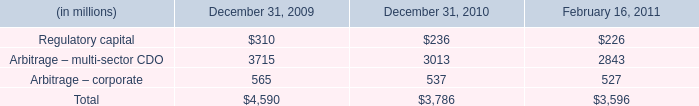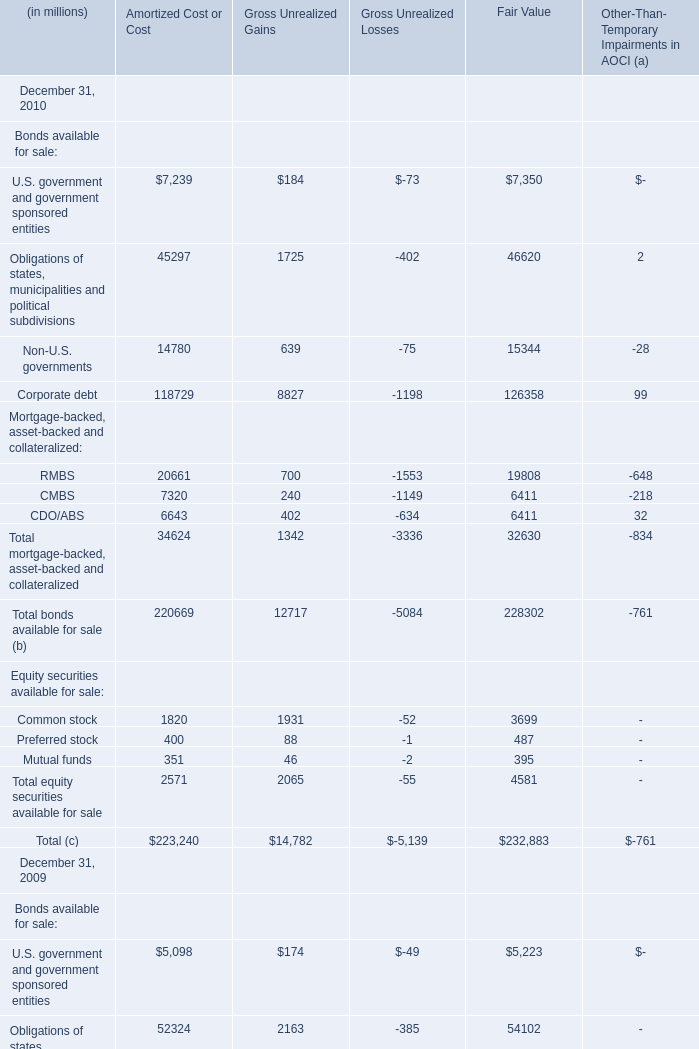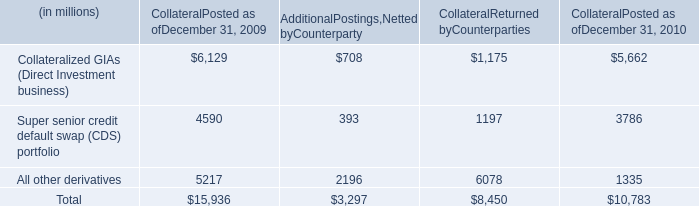What's the average of U.S. government and government sponsored entities and Obligations of states, municipalities and political subdivisions and Non-U.S. governments of Amortized Cost or Cost in 2010? (in millions) 
Computations: (((7239 + 45297) + 14780) / 3)
Answer: 22438.66667. 